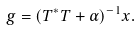Convert formula to latex. <formula><loc_0><loc_0><loc_500><loc_500>g = ( T ^ { * } T + \alpha ) ^ { - 1 } x .</formula> 